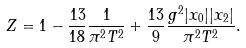<formula> <loc_0><loc_0><loc_500><loc_500>Z = 1 - \frac { 1 3 } { 1 8 } \frac { 1 } { \pi ^ { 2 } T ^ { 2 } } + \frac { 1 3 } { 9 } \frac { g ^ { 2 } | x _ { 0 } | | x _ { 2 } | } { \pi ^ { 2 } T ^ { 2 } } .</formula> 